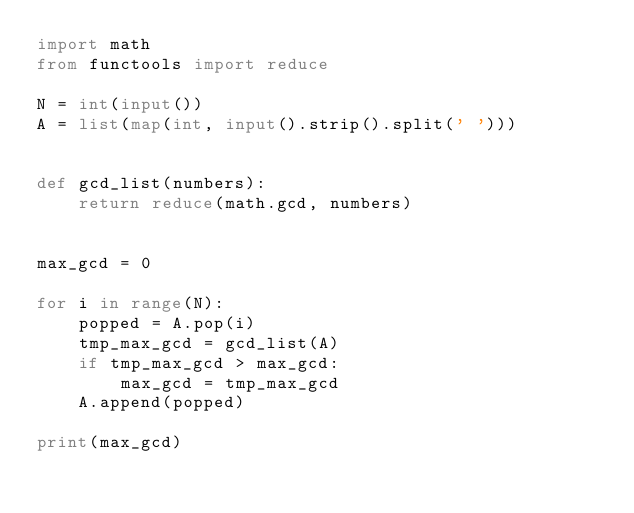<code> <loc_0><loc_0><loc_500><loc_500><_Python_>import math
from functools import reduce

N = int(input())
A = list(map(int, input().strip().split(' ')))


def gcd_list(numbers):
    return reduce(math.gcd, numbers)


max_gcd = 0

for i in range(N):
    popped = A.pop(i)
    tmp_max_gcd = gcd_list(A)
    if tmp_max_gcd > max_gcd:
        max_gcd = tmp_max_gcd
    A.append(popped)

print(max_gcd)
</code> 